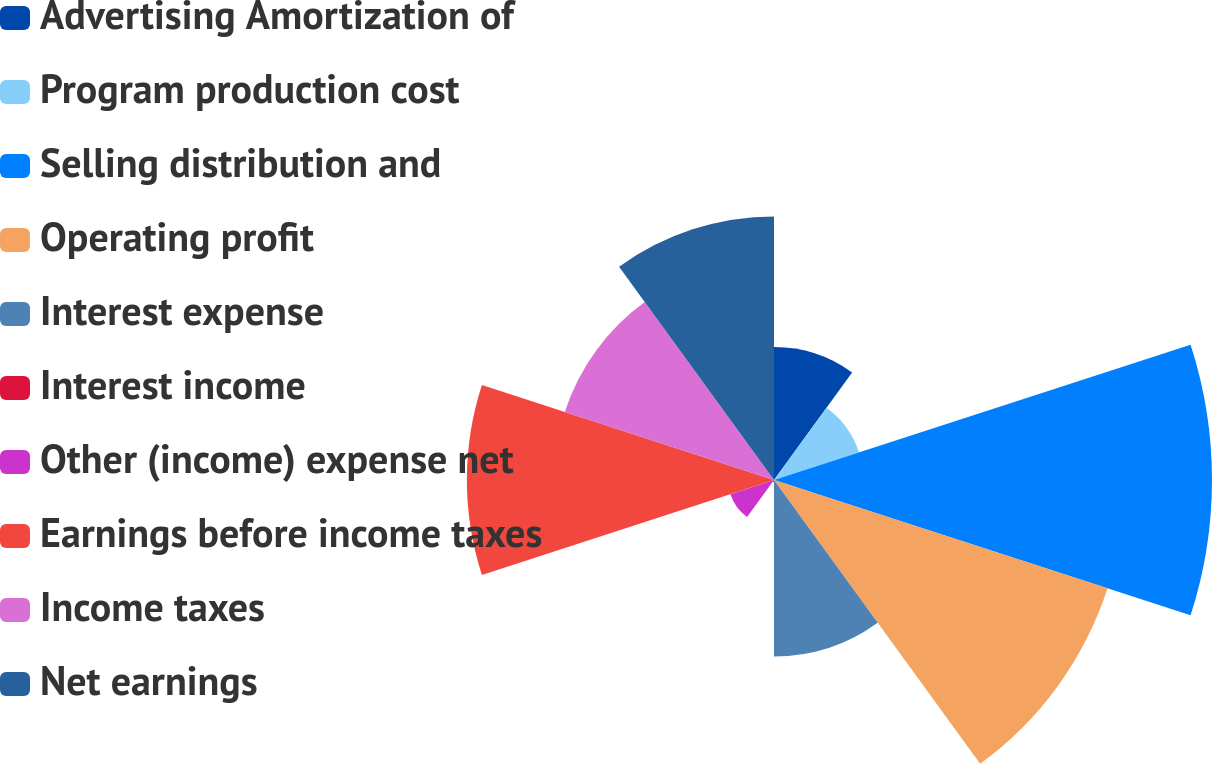Convert chart. <chart><loc_0><loc_0><loc_500><loc_500><pie_chart><fcel>Advertising Amortization of<fcel>Program production cost<fcel>Selling distribution and<fcel>Operating profit<fcel>Interest expense<fcel>Interest income<fcel>Other (income) expense net<fcel>Earnings before income taxes<fcel>Income taxes<fcel>Net earnings<nl><fcel>6.56%<fcel>4.41%<fcel>21.62%<fcel>17.31%<fcel>8.71%<fcel>0.1%<fcel>2.26%<fcel>15.16%<fcel>10.86%<fcel>13.01%<nl></chart> 